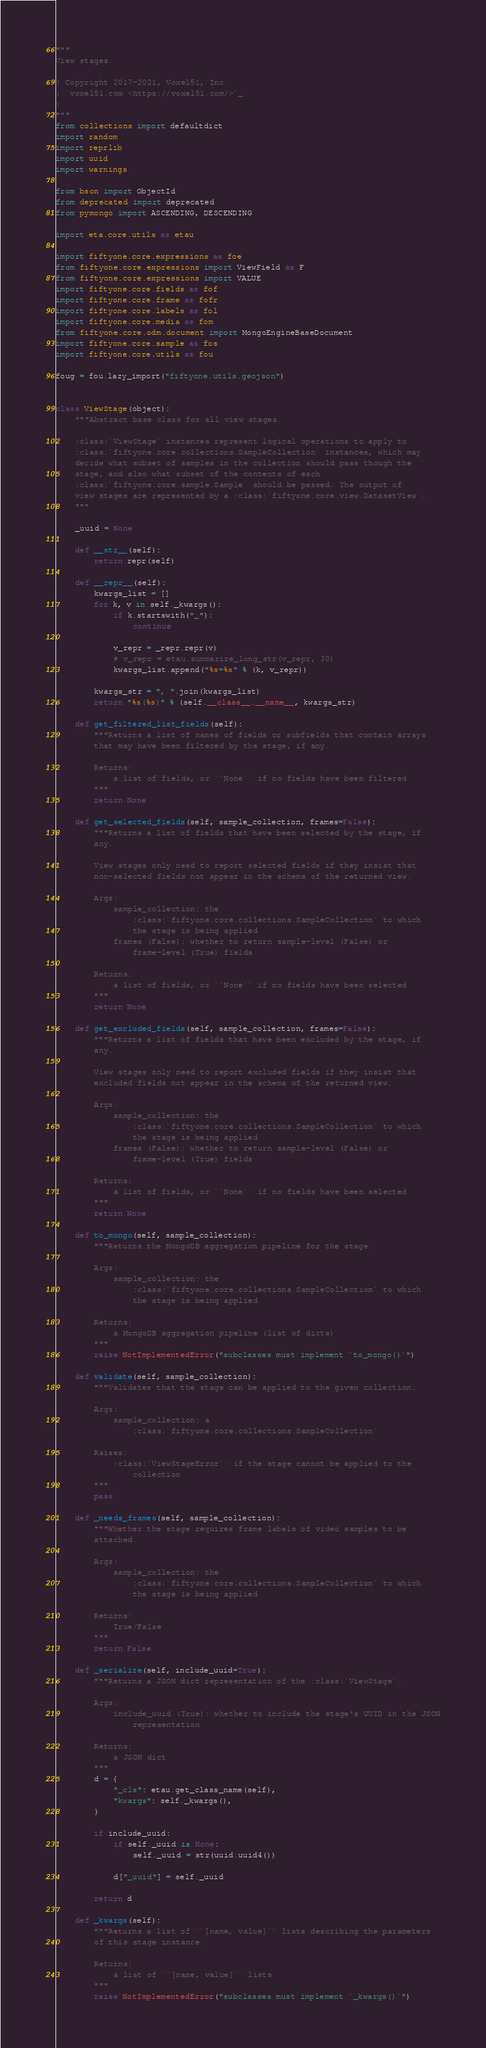<code> <loc_0><loc_0><loc_500><loc_500><_Python_>"""
View stages.

| Copyright 2017-2021, Voxel51, Inc.
| `voxel51.com <https://voxel51.com/>`_
|
"""
from collections import defaultdict
import random
import reprlib
import uuid
import warnings

from bson import ObjectId
from deprecated import deprecated
from pymongo import ASCENDING, DESCENDING

import eta.core.utils as etau

import fiftyone.core.expressions as foe
from fiftyone.core.expressions import ViewField as F
from fiftyone.core.expressions import VALUE
import fiftyone.core.fields as fof
import fiftyone.core.frame as fofr
import fiftyone.core.labels as fol
import fiftyone.core.media as fom
from fiftyone.core.odm.document import MongoEngineBaseDocument
import fiftyone.core.sample as fos
import fiftyone.core.utils as fou

foug = fou.lazy_import("fiftyone.utils.geojson")


class ViewStage(object):
    """Abstract base class for all view stages.

    :class:`ViewStage` instances represent logical operations to apply to
    :class:`fiftyone.core.collections.SampleCollection` instances, which may
    decide what subset of samples in the collection should pass though the
    stage, and also what subset of the contents of each
    :class:`fiftyone.core.sample.Sample` should be passed. The output of
    view stages are represented by a :class:`fiftyone.core.view.DatasetView`.
    """

    _uuid = None

    def __str__(self):
        return repr(self)

    def __repr__(self):
        kwargs_list = []
        for k, v in self._kwargs():
            if k.startswith("_"):
                continue

            v_repr = _repr.repr(v)
            # v_repr = etau.summarize_long_str(v_repr, 30)
            kwargs_list.append("%s=%s" % (k, v_repr))

        kwargs_str = ", ".join(kwargs_list)
        return "%s(%s)" % (self.__class__.__name__, kwargs_str)

    def get_filtered_list_fields(self):
        """Returns a list of names of fields or subfields that contain arrays
        that may have been filtered by the stage, if any.

        Returns:
            a list of fields, or ``None`` if no fields have been filtered
        """
        return None

    def get_selected_fields(self, sample_collection, frames=False):
        """Returns a list of fields that have been selected by the stage, if
        any.

        View stages only need to report selected fields if they insist that
        non-selected fields not appear in the schema of the returned view.

        Args:
            sample_collection: the
                :class:`fiftyone.core.collections.SampleCollection` to which
                the stage is being applied
            frames (False): whether to return sample-level (False) or
                frame-level (True) fields

        Returns:
            a list of fields, or ``None`` if no fields have been selected
        """
        return None

    def get_excluded_fields(self, sample_collection, frames=False):
        """Returns a list of fields that have been excluded by the stage, if
        any.

        View stages only need to report excluded fields if they insist that
        excluded fields not appear in the schema of the returned view.

        Args:
            sample_collection: the
                :class:`fiftyone.core.collections.SampleCollection` to which
                the stage is being applied
            frames (False): whether to return sample-level (False) or
                frame-level (True) fields

        Returns:
            a list of fields, or ``None`` if no fields have been selected
        """
        return None

    def to_mongo(self, sample_collection):
        """Returns the MongoDB aggregation pipeline for the stage.

        Args:
            sample_collection: the
                :class:`fiftyone.core.collections.SampleCollection` to which
                the stage is being applied

        Returns:
            a MongoDB aggregation pipeline (list of dicts)
        """
        raise NotImplementedError("subclasses must implement `to_mongo()`")

    def validate(self, sample_collection):
        """Validates that the stage can be applied to the given collection.

        Args:
            sample_collection: a
                :class:`fiftyone.core.collections.SampleCollection`

        Raises:
            :class:`ViewStageError`: if the stage cannot be applied to the
                collection
        """
        pass

    def _needs_frames(self, sample_collection):
        """Whether the stage requires frame labels of video samples to be
        attached.

        Args:
            sample_collection: the
                :class:`fiftyone.core.collections.SampleCollection` to which
                the stage is being applied

        Returns:
            True/False
        """
        return False

    def _serialize(self, include_uuid=True):
        """Returns a JSON dict representation of the :class:`ViewStage`.

        Args:
            include_uuid (True): whether to include the stage's UUID in the JSON
                representation

        Returns:
            a JSON dict
        """
        d = {
            "_cls": etau.get_class_name(self),
            "kwargs": self._kwargs(),
        }

        if include_uuid:
            if self._uuid is None:
                self._uuid = str(uuid.uuid4())

            d["_uuid"] = self._uuid

        return d

    def _kwargs(self):
        """Returns a list of ``[name, value]`` lists describing the parameters
        of this stage instance.

        Returns:
            a list of ``[name, value]`` lists
        """
        raise NotImplementedError("subclasses must implement `_kwargs()`")
</code> 